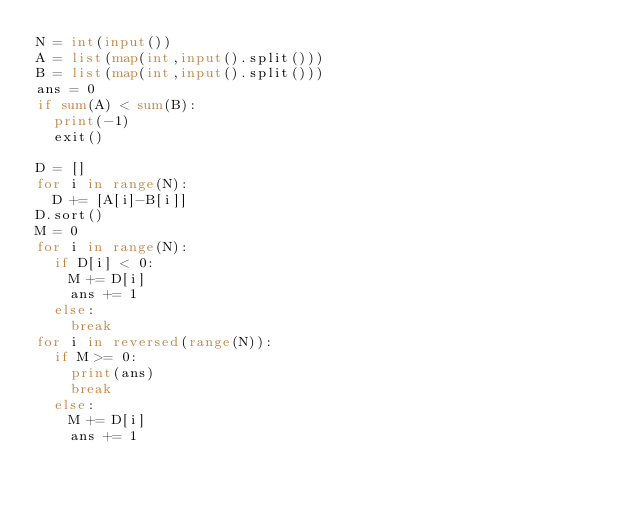<code> <loc_0><loc_0><loc_500><loc_500><_Python_>N = int(input())
A = list(map(int,input().split()))
B = list(map(int,input().split()))
ans = 0
if sum(A) < sum(B):
  print(-1)
  exit()

D = []
for i in range(N):
  D += [A[i]-B[i]]
D.sort()
M = 0
for i in range(N):
  if D[i] < 0:
    M += D[i]
    ans += 1
  else:
    break
for i in reversed(range(N)):
  if M >= 0:
    print(ans)
    break
  else:
    M += D[i]
    ans += 1
</code> 